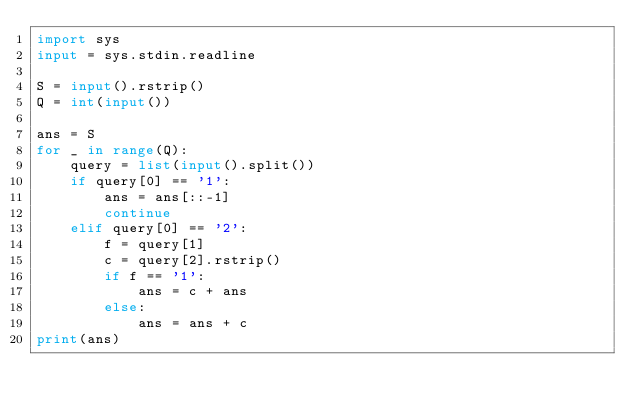<code> <loc_0><loc_0><loc_500><loc_500><_Python_>import sys
input = sys.stdin.readline

S = input().rstrip()
Q = int(input())

ans = S
for _ in range(Q):
    query = list(input().split())
    if query[0] == '1':
        ans = ans[::-1]
        continue
    elif query[0] == '2':
        f = query[1]
        c = query[2].rstrip()
        if f == '1':
            ans = c + ans
        else:
            ans = ans + c
print(ans)
</code> 